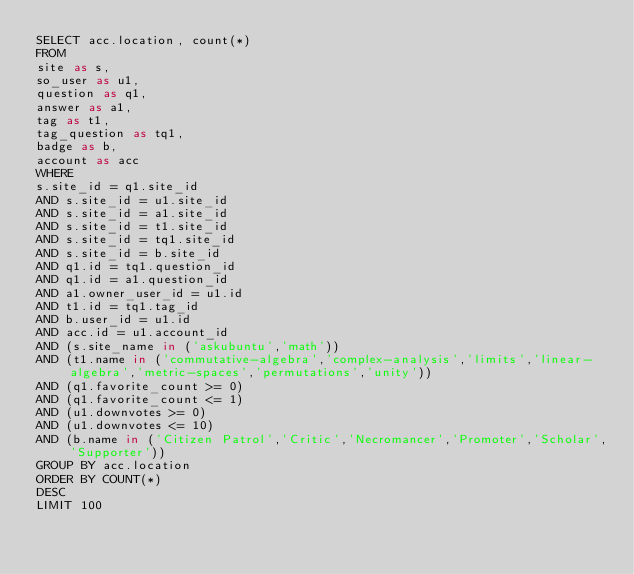Convert code to text. <code><loc_0><loc_0><loc_500><loc_500><_SQL_>SELECT acc.location, count(*)
FROM
site as s,
so_user as u1,
question as q1,
answer as a1,
tag as t1,
tag_question as tq1,
badge as b,
account as acc
WHERE
s.site_id = q1.site_id
AND s.site_id = u1.site_id
AND s.site_id = a1.site_id
AND s.site_id = t1.site_id
AND s.site_id = tq1.site_id
AND s.site_id = b.site_id
AND q1.id = tq1.question_id
AND q1.id = a1.question_id
AND a1.owner_user_id = u1.id
AND t1.id = tq1.tag_id
AND b.user_id = u1.id
AND acc.id = u1.account_id
AND (s.site_name in ('askubuntu','math'))
AND (t1.name in ('commutative-algebra','complex-analysis','limits','linear-algebra','metric-spaces','permutations','unity'))
AND (q1.favorite_count >= 0)
AND (q1.favorite_count <= 1)
AND (u1.downvotes >= 0)
AND (u1.downvotes <= 10)
AND (b.name in ('Citizen Patrol','Critic','Necromancer','Promoter','Scholar','Supporter'))
GROUP BY acc.location
ORDER BY COUNT(*)
DESC
LIMIT 100
</code> 